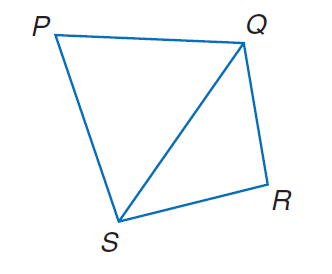Answer the mathemtical geometry problem and directly provide the correct option letter.
Question: In quadrilateral P Q R S, P Q = 721, Q R = 547, R S = 593, P S = 756, and m \angle P = 58. Find Q S.
Choices: A: 345.7 B: 542.5 C: 671.2 D: 716.7 D 